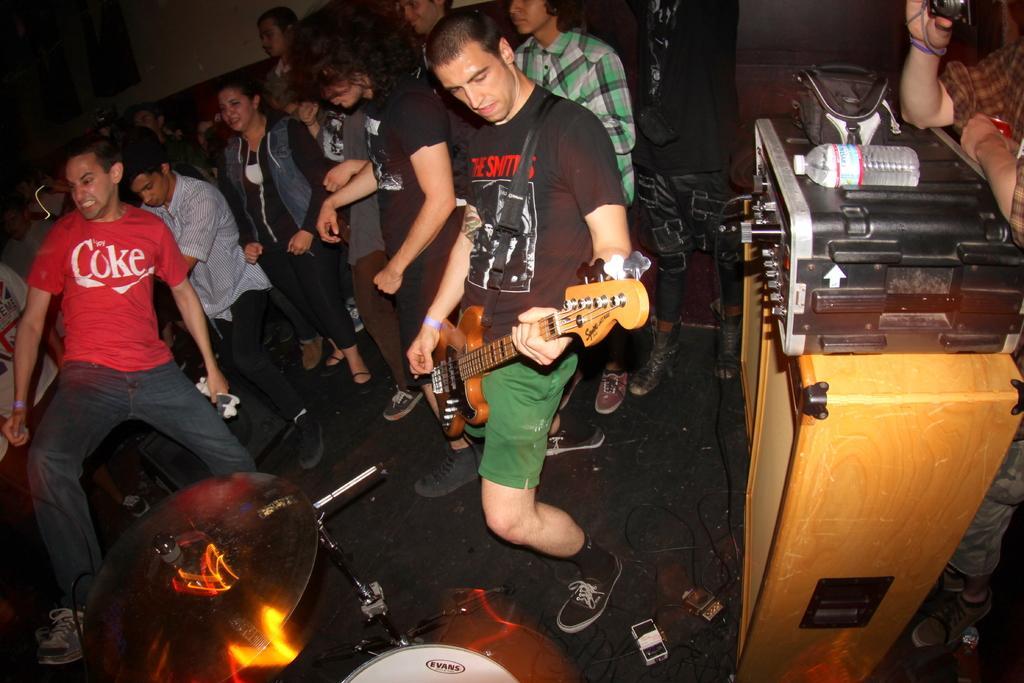How would you summarize this image in a sentence or two? In the image we can see there is a person who is standing and holding guitar in their hand and there are the people who are standing and on the table there is dj box on which there is water bottle and bag and on the ground there is drums and there are wires and connection fittings and there are speakers. 